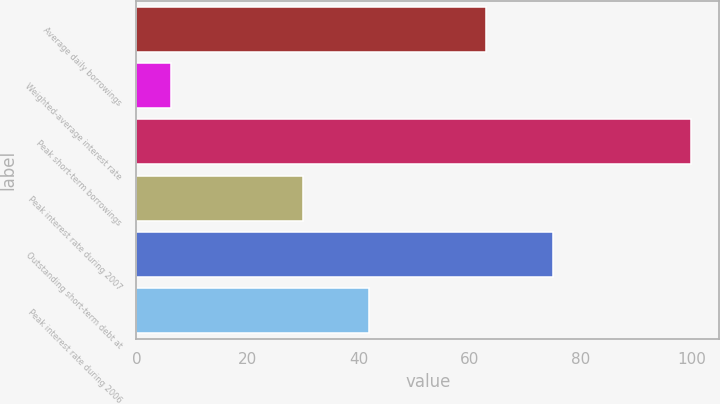Convert chart. <chart><loc_0><loc_0><loc_500><loc_500><bar_chart><fcel>Average daily borrowings<fcel>Weighted-average interest rate<fcel>Peak short-term borrowings<fcel>Peak interest rate during 2007<fcel>Outstanding short-term debt at<fcel>Peak interest rate during 2006<nl><fcel>63<fcel>6.23<fcel>100<fcel>29.99<fcel>75<fcel>41.87<nl></chart> 